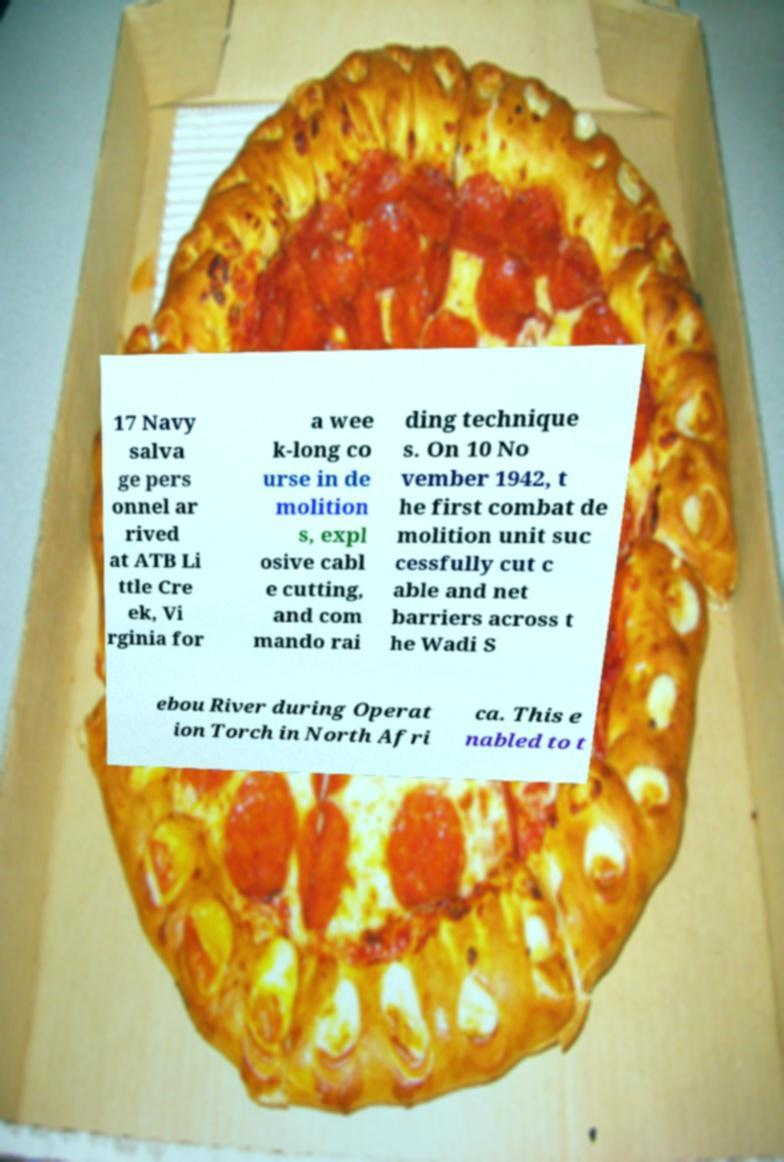Can you accurately transcribe the text from the provided image for me? 17 Navy salva ge pers onnel ar rived at ATB Li ttle Cre ek, Vi rginia for a wee k-long co urse in de molition s, expl osive cabl e cutting, and com mando rai ding technique s. On 10 No vember 1942, t he first combat de molition unit suc cessfully cut c able and net barriers across t he Wadi S ebou River during Operat ion Torch in North Afri ca. This e nabled to t 